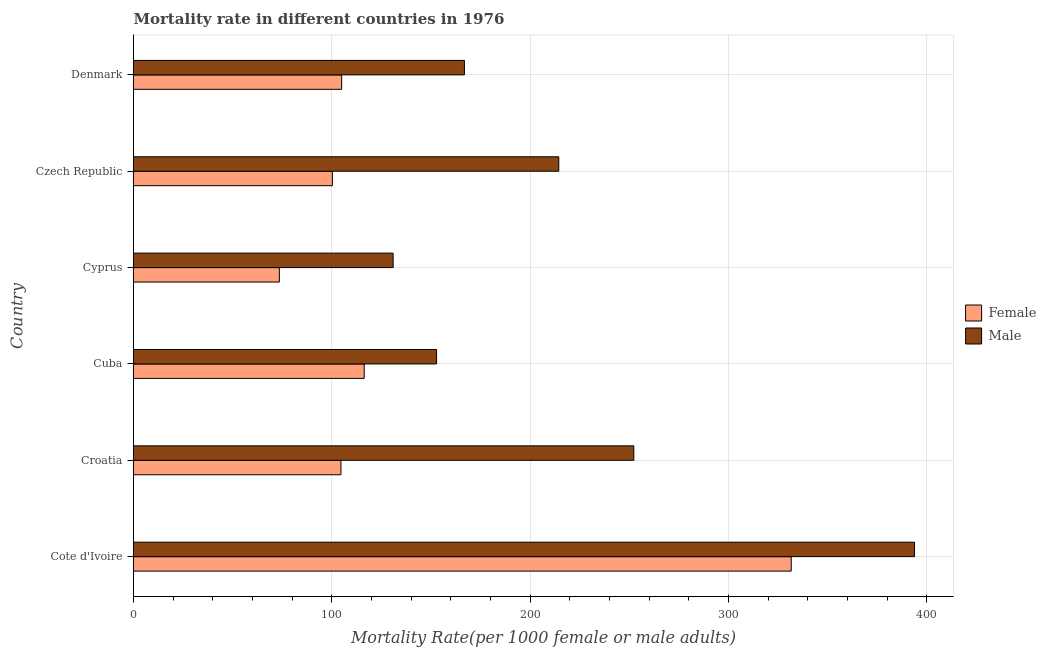How many different coloured bars are there?
Give a very brief answer. 2. Are the number of bars per tick equal to the number of legend labels?
Your answer should be very brief. Yes. Are the number of bars on each tick of the Y-axis equal?
Ensure brevity in your answer.  Yes. How many bars are there on the 2nd tick from the top?
Your response must be concise. 2. How many bars are there on the 4th tick from the bottom?
Your response must be concise. 2. What is the label of the 2nd group of bars from the top?
Ensure brevity in your answer.  Czech Republic. In how many cases, is the number of bars for a given country not equal to the number of legend labels?
Offer a terse response. 0. What is the male mortality rate in Cuba?
Offer a very short reply. 152.84. Across all countries, what is the maximum female mortality rate?
Keep it short and to the point. 331.7. Across all countries, what is the minimum female mortality rate?
Ensure brevity in your answer.  73.54. In which country was the male mortality rate maximum?
Make the answer very short. Cote d'Ivoire. In which country was the female mortality rate minimum?
Give a very brief answer. Cyprus. What is the total male mortality rate in the graph?
Provide a succinct answer. 1311.33. What is the difference between the female mortality rate in Cote d'Ivoire and that in Denmark?
Your response must be concise. 226.73. What is the difference between the female mortality rate in Cyprus and the male mortality rate in Cuba?
Provide a short and direct response. -79.3. What is the average female mortality rate per country?
Give a very brief answer. 138.58. What is the difference between the male mortality rate and female mortality rate in Cuba?
Offer a terse response. 36.49. What is the ratio of the female mortality rate in Cote d'Ivoire to that in Denmark?
Ensure brevity in your answer.  3.16. Is the difference between the female mortality rate in Croatia and Cyprus greater than the difference between the male mortality rate in Croatia and Cyprus?
Your answer should be compact. No. What is the difference between the highest and the second highest female mortality rate?
Offer a very short reply. 215.35. What is the difference between the highest and the lowest female mortality rate?
Make the answer very short. 258.16. In how many countries, is the female mortality rate greater than the average female mortality rate taken over all countries?
Give a very brief answer. 1. Is the sum of the female mortality rate in Cuba and Denmark greater than the maximum male mortality rate across all countries?
Ensure brevity in your answer.  No. What does the 2nd bar from the top in Cyprus represents?
Your answer should be very brief. Female. How many bars are there?
Your answer should be compact. 12. Are the values on the major ticks of X-axis written in scientific E-notation?
Make the answer very short. No. Does the graph contain grids?
Offer a terse response. Yes. Where does the legend appear in the graph?
Keep it short and to the point. Center right. How many legend labels are there?
Offer a very short reply. 2. How are the legend labels stacked?
Keep it short and to the point. Vertical. What is the title of the graph?
Your answer should be very brief. Mortality rate in different countries in 1976. Does "Male labourers" appear as one of the legend labels in the graph?
Your answer should be compact. No. What is the label or title of the X-axis?
Offer a terse response. Mortality Rate(per 1000 female or male adults). What is the Mortality Rate(per 1000 female or male adults) of Female in Cote d'Ivoire?
Give a very brief answer. 331.7. What is the Mortality Rate(per 1000 female or male adults) in Male in Cote d'Ivoire?
Ensure brevity in your answer.  393.88. What is the Mortality Rate(per 1000 female or male adults) of Female in Croatia?
Offer a very short reply. 104.63. What is the Mortality Rate(per 1000 female or male adults) of Male in Croatia?
Give a very brief answer. 252.31. What is the Mortality Rate(per 1000 female or male adults) in Female in Cuba?
Provide a succinct answer. 116.35. What is the Mortality Rate(per 1000 female or male adults) in Male in Cuba?
Ensure brevity in your answer.  152.84. What is the Mortality Rate(per 1000 female or male adults) in Female in Cyprus?
Offer a very short reply. 73.54. What is the Mortality Rate(per 1000 female or male adults) of Male in Cyprus?
Give a very brief answer. 130.94. What is the Mortality Rate(per 1000 female or male adults) of Female in Czech Republic?
Give a very brief answer. 100.29. What is the Mortality Rate(per 1000 female or male adults) of Male in Czech Republic?
Ensure brevity in your answer.  214.47. What is the Mortality Rate(per 1000 female or male adults) in Female in Denmark?
Provide a short and direct response. 104.97. What is the Mortality Rate(per 1000 female or male adults) of Male in Denmark?
Make the answer very short. 166.88. Across all countries, what is the maximum Mortality Rate(per 1000 female or male adults) of Female?
Your answer should be very brief. 331.7. Across all countries, what is the maximum Mortality Rate(per 1000 female or male adults) in Male?
Your answer should be compact. 393.88. Across all countries, what is the minimum Mortality Rate(per 1000 female or male adults) in Female?
Offer a very short reply. 73.54. Across all countries, what is the minimum Mortality Rate(per 1000 female or male adults) in Male?
Your answer should be very brief. 130.94. What is the total Mortality Rate(per 1000 female or male adults) of Female in the graph?
Offer a very short reply. 831.48. What is the total Mortality Rate(per 1000 female or male adults) in Male in the graph?
Ensure brevity in your answer.  1311.33. What is the difference between the Mortality Rate(per 1000 female or male adults) in Female in Cote d'Ivoire and that in Croatia?
Your answer should be very brief. 227.07. What is the difference between the Mortality Rate(per 1000 female or male adults) in Male in Cote d'Ivoire and that in Croatia?
Your answer should be compact. 141.57. What is the difference between the Mortality Rate(per 1000 female or male adults) in Female in Cote d'Ivoire and that in Cuba?
Ensure brevity in your answer.  215.35. What is the difference between the Mortality Rate(per 1000 female or male adults) in Male in Cote d'Ivoire and that in Cuba?
Keep it short and to the point. 241.04. What is the difference between the Mortality Rate(per 1000 female or male adults) in Female in Cote d'Ivoire and that in Cyprus?
Ensure brevity in your answer.  258.16. What is the difference between the Mortality Rate(per 1000 female or male adults) in Male in Cote d'Ivoire and that in Cyprus?
Ensure brevity in your answer.  262.94. What is the difference between the Mortality Rate(per 1000 female or male adults) of Female in Cote d'Ivoire and that in Czech Republic?
Provide a short and direct response. 231.41. What is the difference between the Mortality Rate(per 1000 female or male adults) in Male in Cote d'Ivoire and that in Czech Republic?
Ensure brevity in your answer.  179.41. What is the difference between the Mortality Rate(per 1000 female or male adults) in Female in Cote d'Ivoire and that in Denmark?
Make the answer very short. 226.73. What is the difference between the Mortality Rate(per 1000 female or male adults) in Male in Cote d'Ivoire and that in Denmark?
Provide a succinct answer. 227. What is the difference between the Mortality Rate(per 1000 female or male adults) in Female in Croatia and that in Cuba?
Provide a succinct answer. -11.72. What is the difference between the Mortality Rate(per 1000 female or male adults) in Male in Croatia and that in Cuba?
Your answer should be very brief. 99.47. What is the difference between the Mortality Rate(per 1000 female or male adults) of Female in Croatia and that in Cyprus?
Keep it short and to the point. 31.09. What is the difference between the Mortality Rate(per 1000 female or male adults) of Male in Croatia and that in Cyprus?
Provide a short and direct response. 121.37. What is the difference between the Mortality Rate(per 1000 female or male adults) of Female in Croatia and that in Czech Republic?
Your answer should be compact. 4.34. What is the difference between the Mortality Rate(per 1000 female or male adults) in Male in Croatia and that in Czech Republic?
Provide a succinct answer. 37.84. What is the difference between the Mortality Rate(per 1000 female or male adults) of Female in Croatia and that in Denmark?
Offer a terse response. -0.34. What is the difference between the Mortality Rate(per 1000 female or male adults) of Male in Croatia and that in Denmark?
Your answer should be very brief. 85.43. What is the difference between the Mortality Rate(per 1000 female or male adults) of Female in Cuba and that in Cyprus?
Your answer should be very brief. 42.81. What is the difference between the Mortality Rate(per 1000 female or male adults) of Male in Cuba and that in Cyprus?
Offer a terse response. 21.9. What is the difference between the Mortality Rate(per 1000 female or male adults) in Female in Cuba and that in Czech Republic?
Your response must be concise. 16.05. What is the difference between the Mortality Rate(per 1000 female or male adults) of Male in Cuba and that in Czech Republic?
Offer a very short reply. -61.63. What is the difference between the Mortality Rate(per 1000 female or male adults) of Female in Cuba and that in Denmark?
Your answer should be compact. 11.38. What is the difference between the Mortality Rate(per 1000 female or male adults) of Male in Cuba and that in Denmark?
Your answer should be very brief. -14.04. What is the difference between the Mortality Rate(per 1000 female or male adults) of Female in Cyprus and that in Czech Republic?
Your answer should be very brief. -26.75. What is the difference between the Mortality Rate(per 1000 female or male adults) of Male in Cyprus and that in Czech Republic?
Offer a terse response. -83.54. What is the difference between the Mortality Rate(per 1000 female or male adults) of Female in Cyprus and that in Denmark?
Your answer should be compact. -31.43. What is the difference between the Mortality Rate(per 1000 female or male adults) in Male in Cyprus and that in Denmark?
Offer a very short reply. -35.94. What is the difference between the Mortality Rate(per 1000 female or male adults) of Female in Czech Republic and that in Denmark?
Your answer should be compact. -4.68. What is the difference between the Mortality Rate(per 1000 female or male adults) of Male in Czech Republic and that in Denmark?
Offer a terse response. 47.59. What is the difference between the Mortality Rate(per 1000 female or male adults) of Female in Cote d'Ivoire and the Mortality Rate(per 1000 female or male adults) of Male in Croatia?
Your answer should be very brief. 79.39. What is the difference between the Mortality Rate(per 1000 female or male adults) of Female in Cote d'Ivoire and the Mortality Rate(per 1000 female or male adults) of Male in Cuba?
Your response must be concise. 178.86. What is the difference between the Mortality Rate(per 1000 female or male adults) of Female in Cote d'Ivoire and the Mortality Rate(per 1000 female or male adults) of Male in Cyprus?
Your answer should be compact. 200.76. What is the difference between the Mortality Rate(per 1000 female or male adults) in Female in Cote d'Ivoire and the Mortality Rate(per 1000 female or male adults) in Male in Czech Republic?
Provide a short and direct response. 117.23. What is the difference between the Mortality Rate(per 1000 female or male adults) in Female in Cote d'Ivoire and the Mortality Rate(per 1000 female or male adults) in Male in Denmark?
Ensure brevity in your answer.  164.82. What is the difference between the Mortality Rate(per 1000 female or male adults) in Female in Croatia and the Mortality Rate(per 1000 female or male adults) in Male in Cuba?
Give a very brief answer. -48.21. What is the difference between the Mortality Rate(per 1000 female or male adults) in Female in Croatia and the Mortality Rate(per 1000 female or male adults) in Male in Cyprus?
Your answer should be compact. -26.31. What is the difference between the Mortality Rate(per 1000 female or male adults) in Female in Croatia and the Mortality Rate(per 1000 female or male adults) in Male in Czech Republic?
Your response must be concise. -109.85. What is the difference between the Mortality Rate(per 1000 female or male adults) of Female in Croatia and the Mortality Rate(per 1000 female or male adults) of Male in Denmark?
Ensure brevity in your answer.  -62.25. What is the difference between the Mortality Rate(per 1000 female or male adults) in Female in Cuba and the Mortality Rate(per 1000 female or male adults) in Male in Cyprus?
Provide a short and direct response. -14.59. What is the difference between the Mortality Rate(per 1000 female or male adults) of Female in Cuba and the Mortality Rate(per 1000 female or male adults) of Male in Czech Republic?
Your answer should be very brief. -98.13. What is the difference between the Mortality Rate(per 1000 female or male adults) of Female in Cuba and the Mortality Rate(per 1000 female or male adults) of Male in Denmark?
Offer a very short reply. -50.53. What is the difference between the Mortality Rate(per 1000 female or male adults) of Female in Cyprus and the Mortality Rate(per 1000 female or male adults) of Male in Czech Republic?
Ensure brevity in your answer.  -140.93. What is the difference between the Mortality Rate(per 1000 female or male adults) in Female in Cyprus and the Mortality Rate(per 1000 female or male adults) in Male in Denmark?
Offer a very short reply. -93.34. What is the difference between the Mortality Rate(per 1000 female or male adults) of Female in Czech Republic and the Mortality Rate(per 1000 female or male adults) of Male in Denmark?
Keep it short and to the point. -66.59. What is the average Mortality Rate(per 1000 female or male adults) in Female per country?
Make the answer very short. 138.58. What is the average Mortality Rate(per 1000 female or male adults) in Male per country?
Make the answer very short. 218.55. What is the difference between the Mortality Rate(per 1000 female or male adults) of Female and Mortality Rate(per 1000 female or male adults) of Male in Cote d'Ivoire?
Your answer should be compact. -62.18. What is the difference between the Mortality Rate(per 1000 female or male adults) in Female and Mortality Rate(per 1000 female or male adults) in Male in Croatia?
Provide a succinct answer. -147.68. What is the difference between the Mortality Rate(per 1000 female or male adults) of Female and Mortality Rate(per 1000 female or male adults) of Male in Cuba?
Offer a terse response. -36.49. What is the difference between the Mortality Rate(per 1000 female or male adults) in Female and Mortality Rate(per 1000 female or male adults) in Male in Cyprus?
Ensure brevity in your answer.  -57.4. What is the difference between the Mortality Rate(per 1000 female or male adults) of Female and Mortality Rate(per 1000 female or male adults) of Male in Czech Republic?
Offer a very short reply. -114.18. What is the difference between the Mortality Rate(per 1000 female or male adults) of Female and Mortality Rate(per 1000 female or male adults) of Male in Denmark?
Provide a succinct answer. -61.91. What is the ratio of the Mortality Rate(per 1000 female or male adults) of Female in Cote d'Ivoire to that in Croatia?
Provide a succinct answer. 3.17. What is the ratio of the Mortality Rate(per 1000 female or male adults) of Male in Cote d'Ivoire to that in Croatia?
Ensure brevity in your answer.  1.56. What is the ratio of the Mortality Rate(per 1000 female or male adults) in Female in Cote d'Ivoire to that in Cuba?
Your answer should be compact. 2.85. What is the ratio of the Mortality Rate(per 1000 female or male adults) of Male in Cote d'Ivoire to that in Cuba?
Ensure brevity in your answer.  2.58. What is the ratio of the Mortality Rate(per 1000 female or male adults) in Female in Cote d'Ivoire to that in Cyprus?
Your answer should be very brief. 4.51. What is the ratio of the Mortality Rate(per 1000 female or male adults) of Male in Cote d'Ivoire to that in Cyprus?
Ensure brevity in your answer.  3.01. What is the ratio of the Mortality Rate(per 1000 female or male adults) in Female in Cote d'Ivoire to that in Czech Republic?
Ensure brevity in your answer.  3.31. What is the ratio of the Mortality Rate(per 1000 female or male adults) in Male in Cote d'Ivoire to that in Czech Republic?
Offer a very short reply. 1.84. What is the ratio of the Mortality Rate(per 1000 female or male adults) of Female in Cote d'Ivoire to that in Denmark?
Provide a short and direct response. 3.16. What is the ratio of the Mortality Rate(per 1000 female or male adults) of Male in Cote d'Ivoire to that in Denmark?
Offer a terse response. 2.36. What is the ratio of the Mortality Rate(per 1000 female or male adults) of Female in Croatia to that in Cuba?
Your response must be concise. 0.9. What is the ratio of the Mortality Rate(per 1000 female or male adults) of Male in Croatia to that in Cuba?
Ensure brevity in your answer.  1.65. What is the ratio of the Mortality Rate(per 1000 female or male adults) in Female in Croatia to that in Cyprus?
Provide a succinct answer. 1.42. What is the ratio of the Mortality Rate(per 1000 female or male adults) of Male in Croatia to that in Cyprus?
Ensure brevity in your answer.  1.93. What is the ratio of the Mortality Rate(per 1000 female or male adults) in Female in Croatia to that in Czech Republic?
Your response must be concise. 1.04. What is the ratio of the Mortality Rate(per 1000 female or male adults) in Male in Croatia to that in Czech Republic?
Keep it short and to the point. 1.18. What is the ratio of the Mortality Rate(per 1000 female or male adults) of Male in Croatia to that in Denmark?
Your answer should be very brief. 1.51. What is the ratio of the Mortality Rate(per 1000 female or male adults) in Female in Cuba to that in Cyprus?
Provide a succinct answer. 1.58. What is the ratio of the Mortality Rate(per 1000 female or male adults) of Male in Cuba to that in Cyprus?
Provide a short and direct response. 1.17. What is the ratio of the Mortality Rate(per 1000 female or male adults) in Female in Cuba to that in Czech Republic?
Provide a short and direct response. 1.16. What is the ratio of the Mortality Rate(per 1000 female or male adults) in Male in Cuba to that in Czech Republic?
Ensure brevity in your answer.  0.71. What is the ratio of the Mortality Rate(per 1000 female or male adults) in Female in Cuba to that in Denmark?
Make the answer very short. 1.11. What is the ratio of the Mortality Rate(per 1000 female or male adults) of Male in Cuba to that in Denmark?
Offer a terse response. 0.92. What is the ratio of the Mortality Rate(per 1000 female or male adults) of Female in Cyprus to that in Czech Republic?
Provide a short and direct response. 0.73. What is the ratio of the Mortality Rate(per 1000 female or male adults) in Male in Cyprus to that in Czech Republic?
Your response must be concise. 0.61. What is the ratio of the Mortality Rate(per 1000 female or male adults) of Female in Cyprus to that in Denmark?
Give a very brief answer. 0.7. What is the ratio of the Mortality Rate(per 1000 female or male adults) in Male in Cyprus to that in Denmark?
Your response must be concise. 0.78. What is the ratio of the Mortality Rate(per 1000 female or male adults) in Female in Czech Republic to that in Denmark?
Your answer should be compact. 0.96. What is the ratio of the Mortality Rate(per 1000 female or male adults) in Male in Czech Republic to that in Denmark?
Your answer should be compact. 1.29. What is the difference between the highest and the second highest Mortality Rate(per 1000 female or male adults) in Female?
Provide a short and direct response. 215.35. What is the difference between the highest and the second highest Mortality Rate(per 1000 female or male adults) of Male?
Your response must be concise. 141.57. What is the difference between the highest and the lowest Mortality Rate(per 1000 female or male adults) in Female?
Make the answer very short. 258.16. What is the difference between the highest and the lowest Mortality Rate(per 1000 female or male adults) of Male?
Provide a short and direct response. 262.94. 